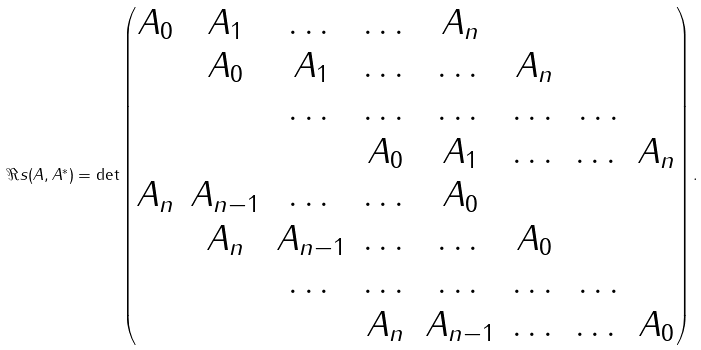<formula> <loc_0><loc_0><loc_500><loc_500>\Re s ( A , A ^ { * } ) = \det \begin{pmatrix} A _ { 0 } & A _ { 1 } & \dots & \dots & A _ { n } & \\ & A _ { 0 } & A _ { 1 } & \dots & \dots & A _ { n } \\ & & \dots & \dots & \dots & \dots & \dots \\ & & & A _ { 0 } & A _ { 1 } & \dots & \dots & A _ { n } \\ A _ { n } & A _ { n - 1 } & \dots & \dots & A _ { 0 } & \\ & A _ { n } & A _ { n - 1 } & \dots & \dots & A _ { 0 } \\ & & \dots & \dots & \dots & \dots & \dots \\ & & & A _ { n } & A _ { n - 1 } & \dots & \dots & A _ { 0 } \\ \end{pmatrix} .</formula> 